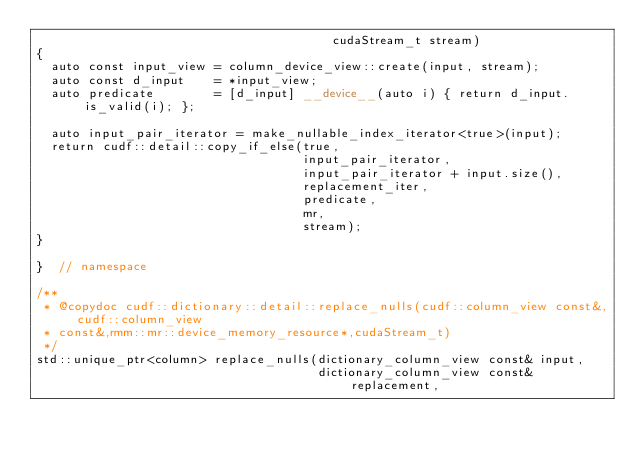Convert code to text. <code><loc_0><loc_0><loc_500><loc_500><_Cuda_>                                        cudaStream_t stream)
{
  auto const input_view = column_device_view::create(input, stream);
  auto const d_input    = *input_view;
  auto predicate        = [d_input] __device__(auto i) { return d_input.is_valid(i); };

  auto input_pair_iterator = make_nullable_index_iterator<true>(input);
  return cudf::detail::copy_if_else(true,
                                    input_pair_iterator,
                                    input_pair_iterator + input.size(),
                                    replacement_iter,
                                    predicate,
                                    mr,
                                    stream);
}

}  // namespace

/**
 * @copydoc cudf::dictionary::detail::replace_nulls(cudf::column_view const&,cudf::column_view
 * const&,rmm::mr::device_memory_resource*,cudaStream_t)
 */
std::unique_ptr<column> replace_nulls(dictionary_column_view const& input,
                                      dictionary_column_view const& replacement,</code> 